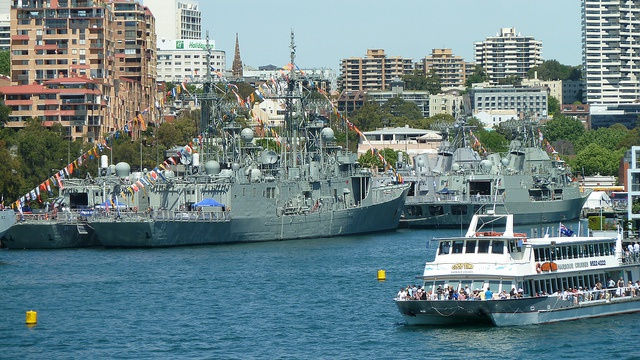Describe the objects in this image and their specific colors. I can see boat in lightgray, gray, darkgray, and black tones, boat in lightgray, white, black, gray, and darkgray tones, boat in lightgray, darkgray, gray, and blue tones, people in lightgray and gray tones, and people in lightgray, gray, teal, and lightblue tones in this image. 